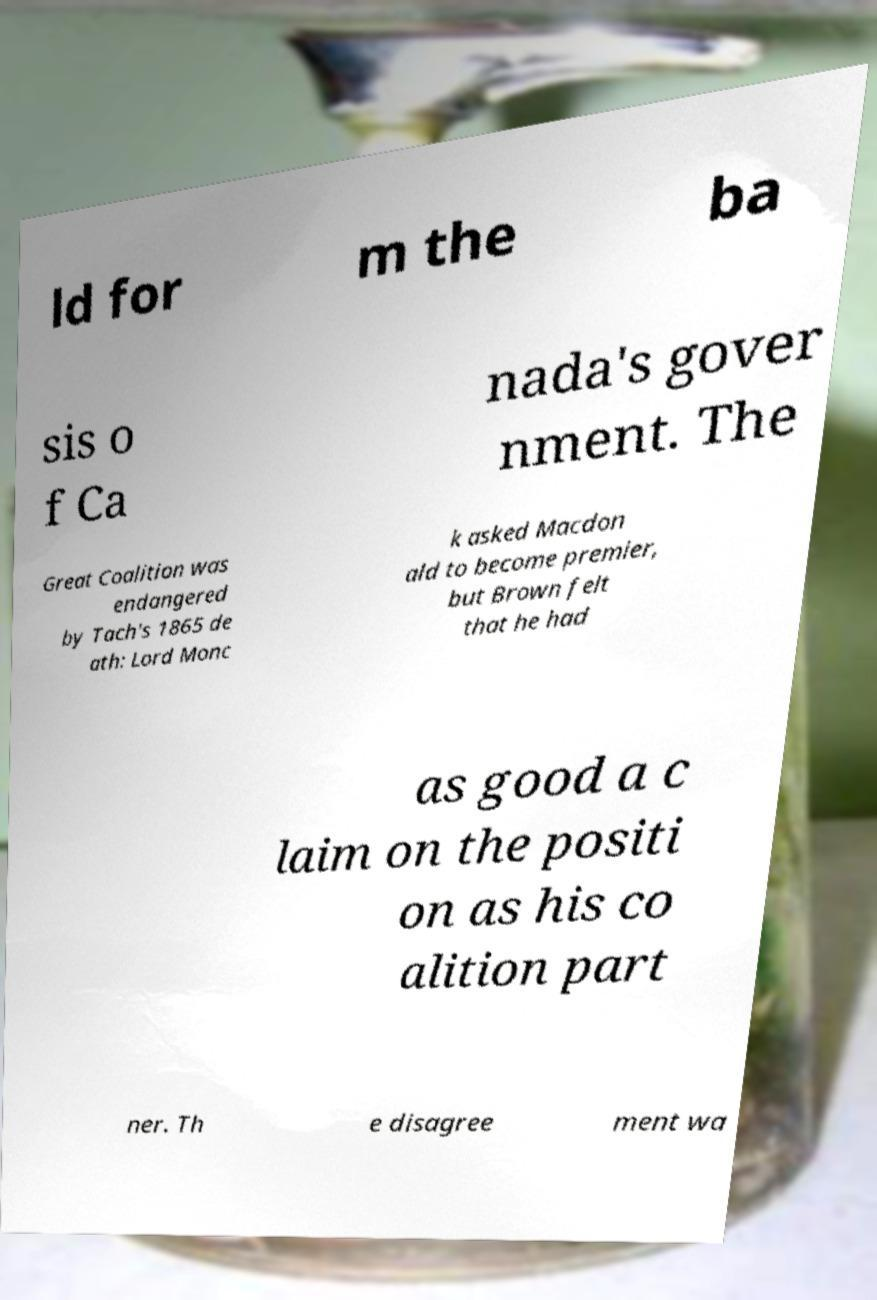For documentation purposes, I need the text within this image transcribed. Could you provide that? ld for m the ba sis o f Ca nada's gover nment. The Great Coalition was endangered by Tach's 1865 de ath: Lord Monc k asked Macdon ald to become premier, but Brown felt that he had as good a c laim on the positi on as his co alition part ner. Th e disagree ment wa 